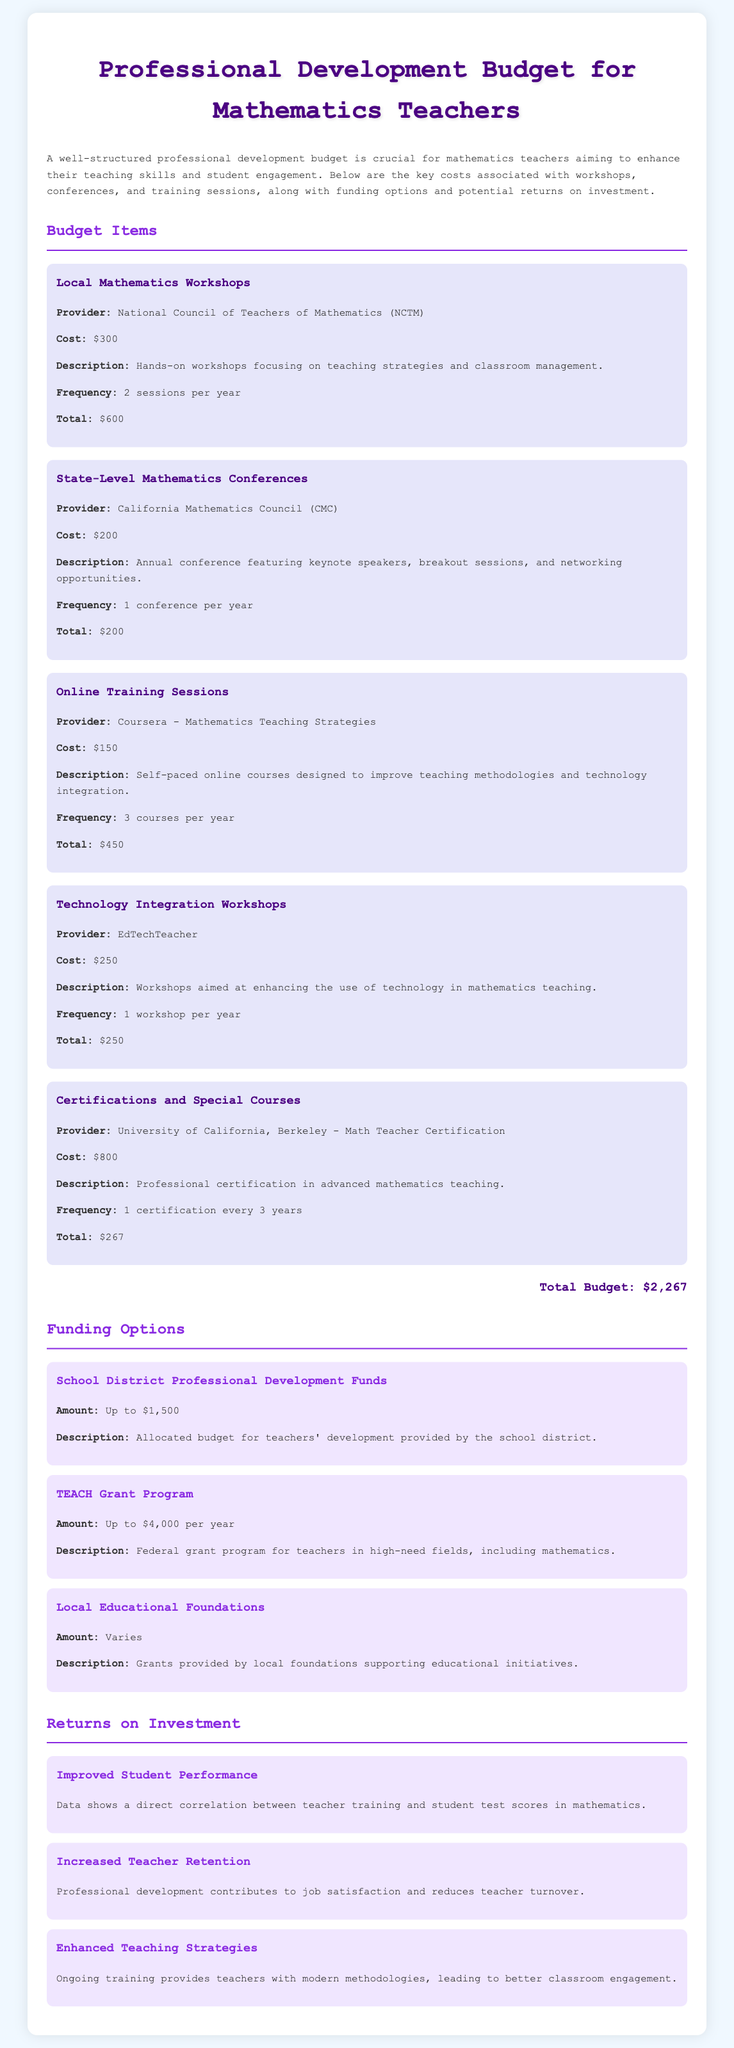What is the cost of the Local Mathematics Workshops? The cost of the Local Mathematics Workshops is provided in the budget section of the document, which states $300.
Answer: $300 How many online training sessions are planned per year? The frequency for online training sessions is mentioned as 3 courses per year in the document.
Answer: 3 courses What is the total budget allocated for technology integration workshops? The total cost for the technology integration workshops is specified as $250 in the document.
Answer: $250 What funding option offers up to $4,000 per year? The TEACH Grant Program is listed in the funding options and specifies an amount of up to $4,000 per year.
Answer: TEACH Grant Program How often is the certification course taken? The frequency for certifications and special courses is indicated as 1 certification every 3 years in the document.
Answer: 1 certification every 3 years What correlation is mentioned regarding professional development? The document states a direct correlation between teacher training and student test scores in mathematics.
Answer: Improved Student Performance What is the provider for online training sessions? The online training sessions are provided by Coursera, specifically for Mathematics Teaching Strategies.
Answer: Coursera What is the total budget amount stated in the document? The total budget amount is calculated and reported at the end of the budget section as $2,267.
Answer: $2,267 